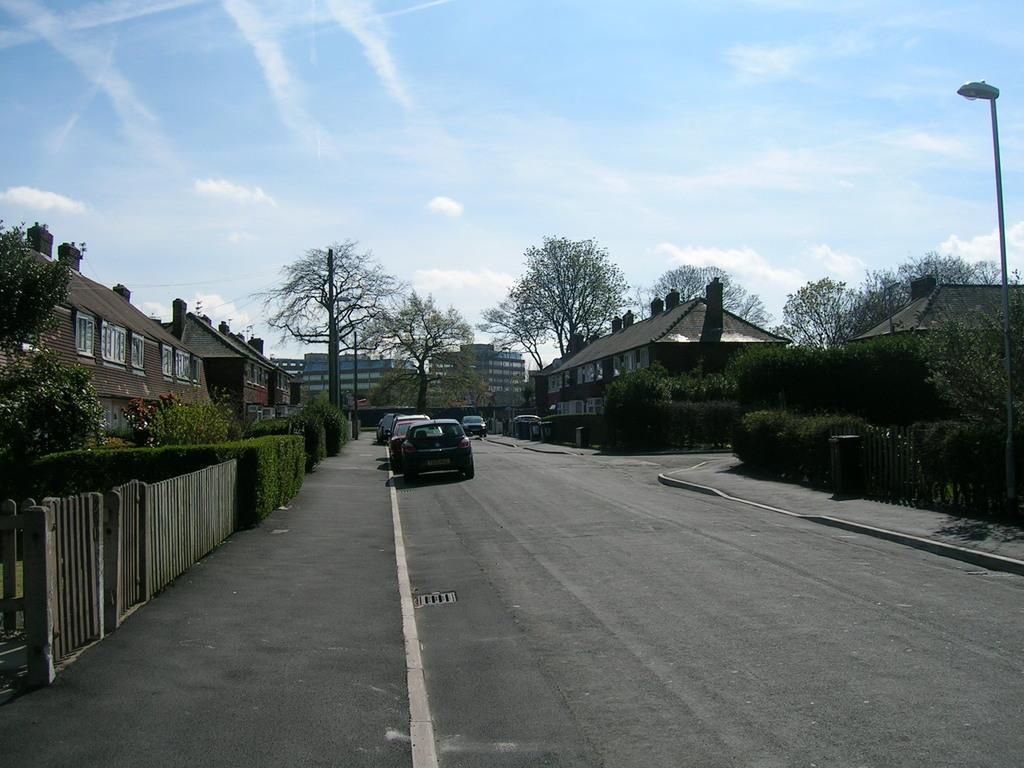In one or two sentences, can you explain what this image depicts? This picture is clicked outside the city. At the bottom of the picture, we see the vehicles are moving on the road. On the right side, we see a street light. On either side of the picture, we see shrubs, trees and buildings. On the left side, we see a railing. There are buildings and trees in the background. At the top of the picture, we see the sky. 